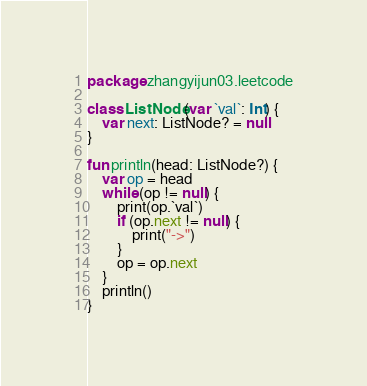Convert code to text. <code><loc_0><loc_0><loc_500><loc_500><_Kotlin_>package zhangyijun03.leetcode

class ListNode(var `val`: Int) {
    var next: ListNode? = null
}

fun println(head: ListNode?) {
    var op = head
    while (op != null) {
        print(op.`val`)
        if (op.next != null) {
            print("->")
        }
        op = op.next
    }
    println()
}</code> 